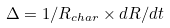Convert formula to latex. <formula><loc_0><loc_0><loc_500><loc_500>\Delta = 1 / R _ { c h a r } \times d R / d t</formula> 